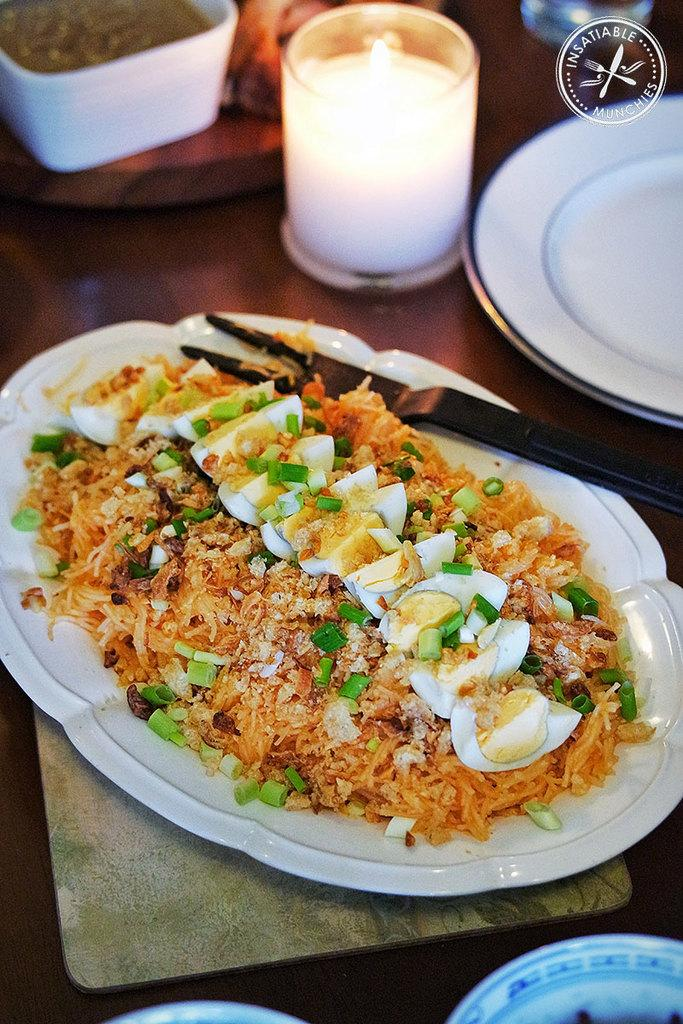What type of table is in the image? There is a brown table in the image. What is on the table? A plate containing food, a fork, bowls, an empty plate, a bowl containing food, and a candle are on the table. How many plates are on the table? There are two plates on the table, one containing food and one empty. What is the purpose of the candle on the table? The purpose of the candle on the table is not specified, but it could be for lighting or decoration. What type of feast is being held in the image? There is no indication of a feast being held in the image; it simply shows a table with various items on it. Can you see a tiger in the image? No, there is no tiger present in the image. 